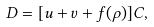Convert formula to latex. <formula><loc_0><loc_0><loc_500><loc_500>D = [ u + v + f ( \rho ) ] C ,</formula> 